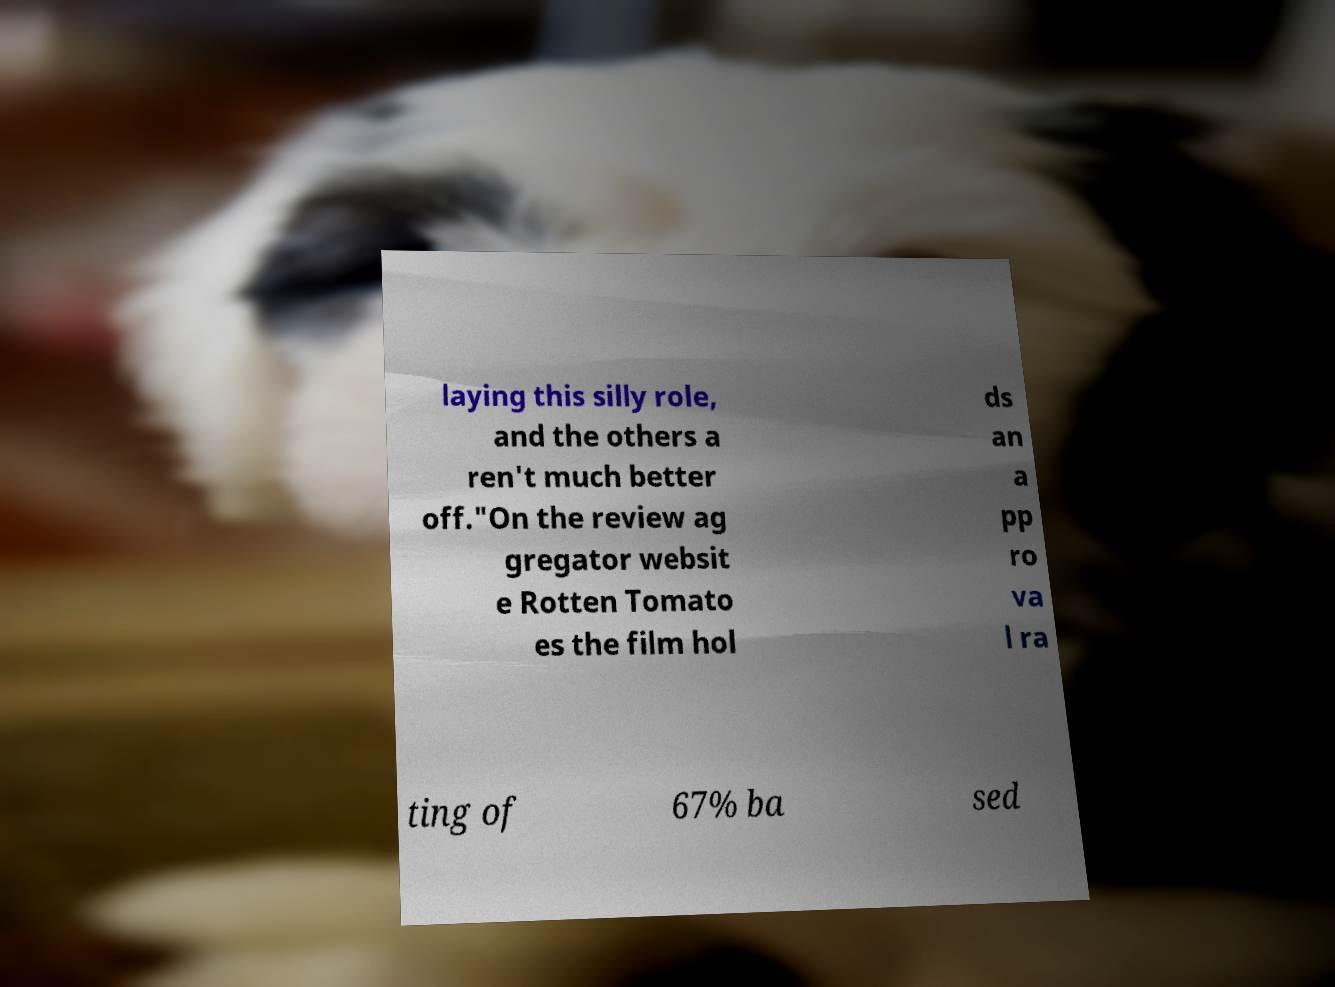Can you read and provide the text displayed in the image?This photo seems to have some interesting text. Can you extract and type it out for me? laying this silly role, and the others a ren't much better off."On the review ag gregator websit e Rotten Tomato es the film hol ds an a pp ro va l ra ting of 67% ba sed 